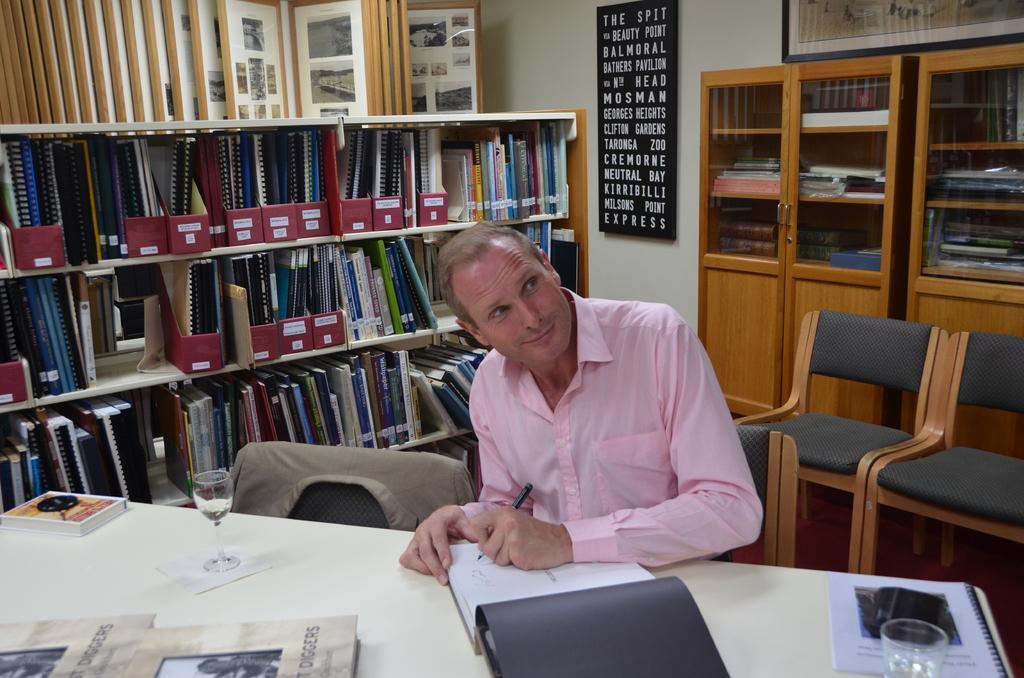Can you describe this image briefly? In the foreground of this image, there are books glasses, a black object and a tissue on the table. In the middle, there is a man sitting and holding a pen. Beside of him, there is a coat on a chair. Behind him, there are books, files and few objects in the shelves and cupboards. We can also see frames on wall and two chairs on the right. 